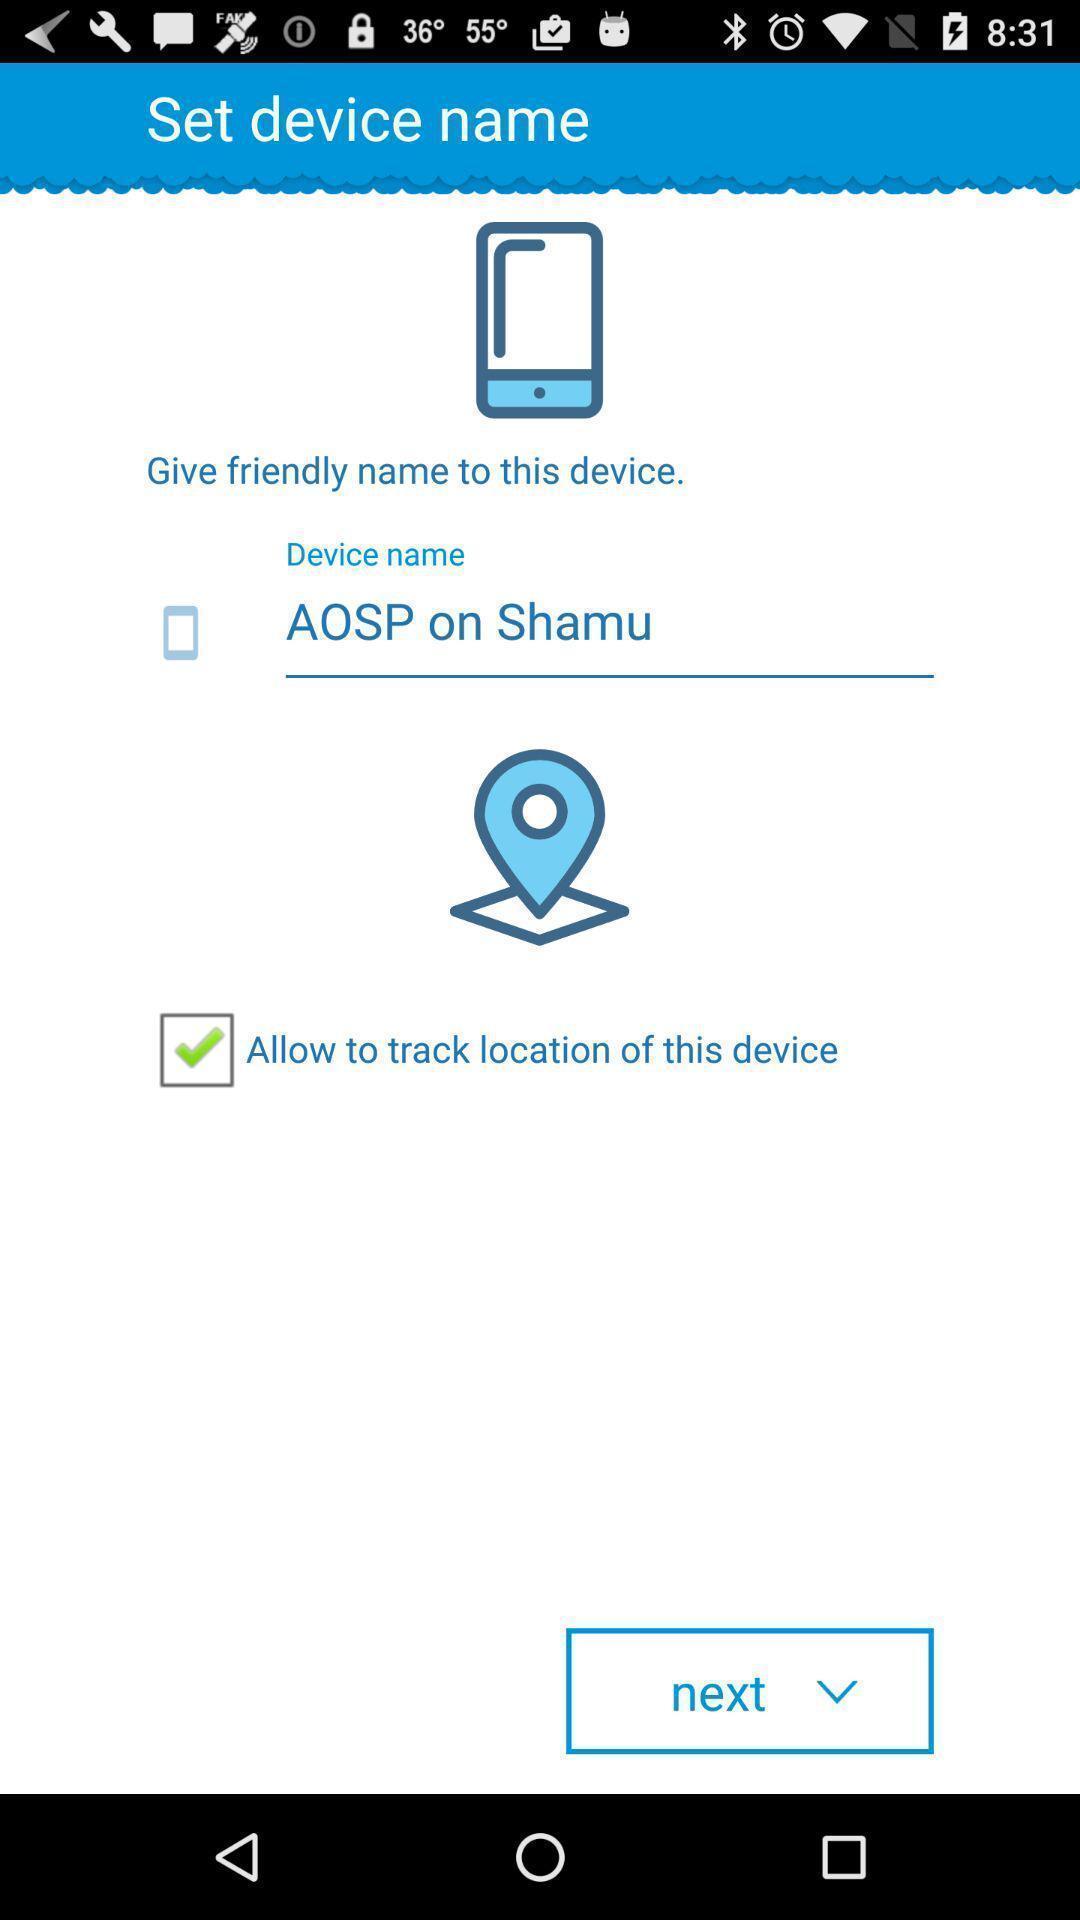Provide a textual representation of this image. Page showing the name of the device with next button. 